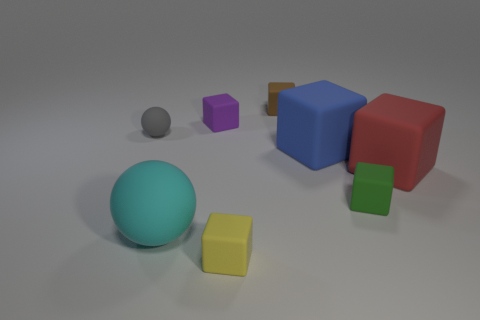Subtract all blue cubes. How many cubes are left? 5 Subtract all tiny brown blocks. How many blocks are left? 5 Subtract all red cubes. Subtract all green cylinders. How many cubes are left? 5 Add 1 green cubes. How many objects exist? 9 Subtract all balls. How many objects are left? 6 Subtract all gray spheres. Subtract all green things. How many objects are left? 6 Add 4 large red cubes. How many large red cubes are left? 5 Add 2 small blocks. How many small blocks exist? 6 Subtract 0 brown spheres. How many objects are left? 8 